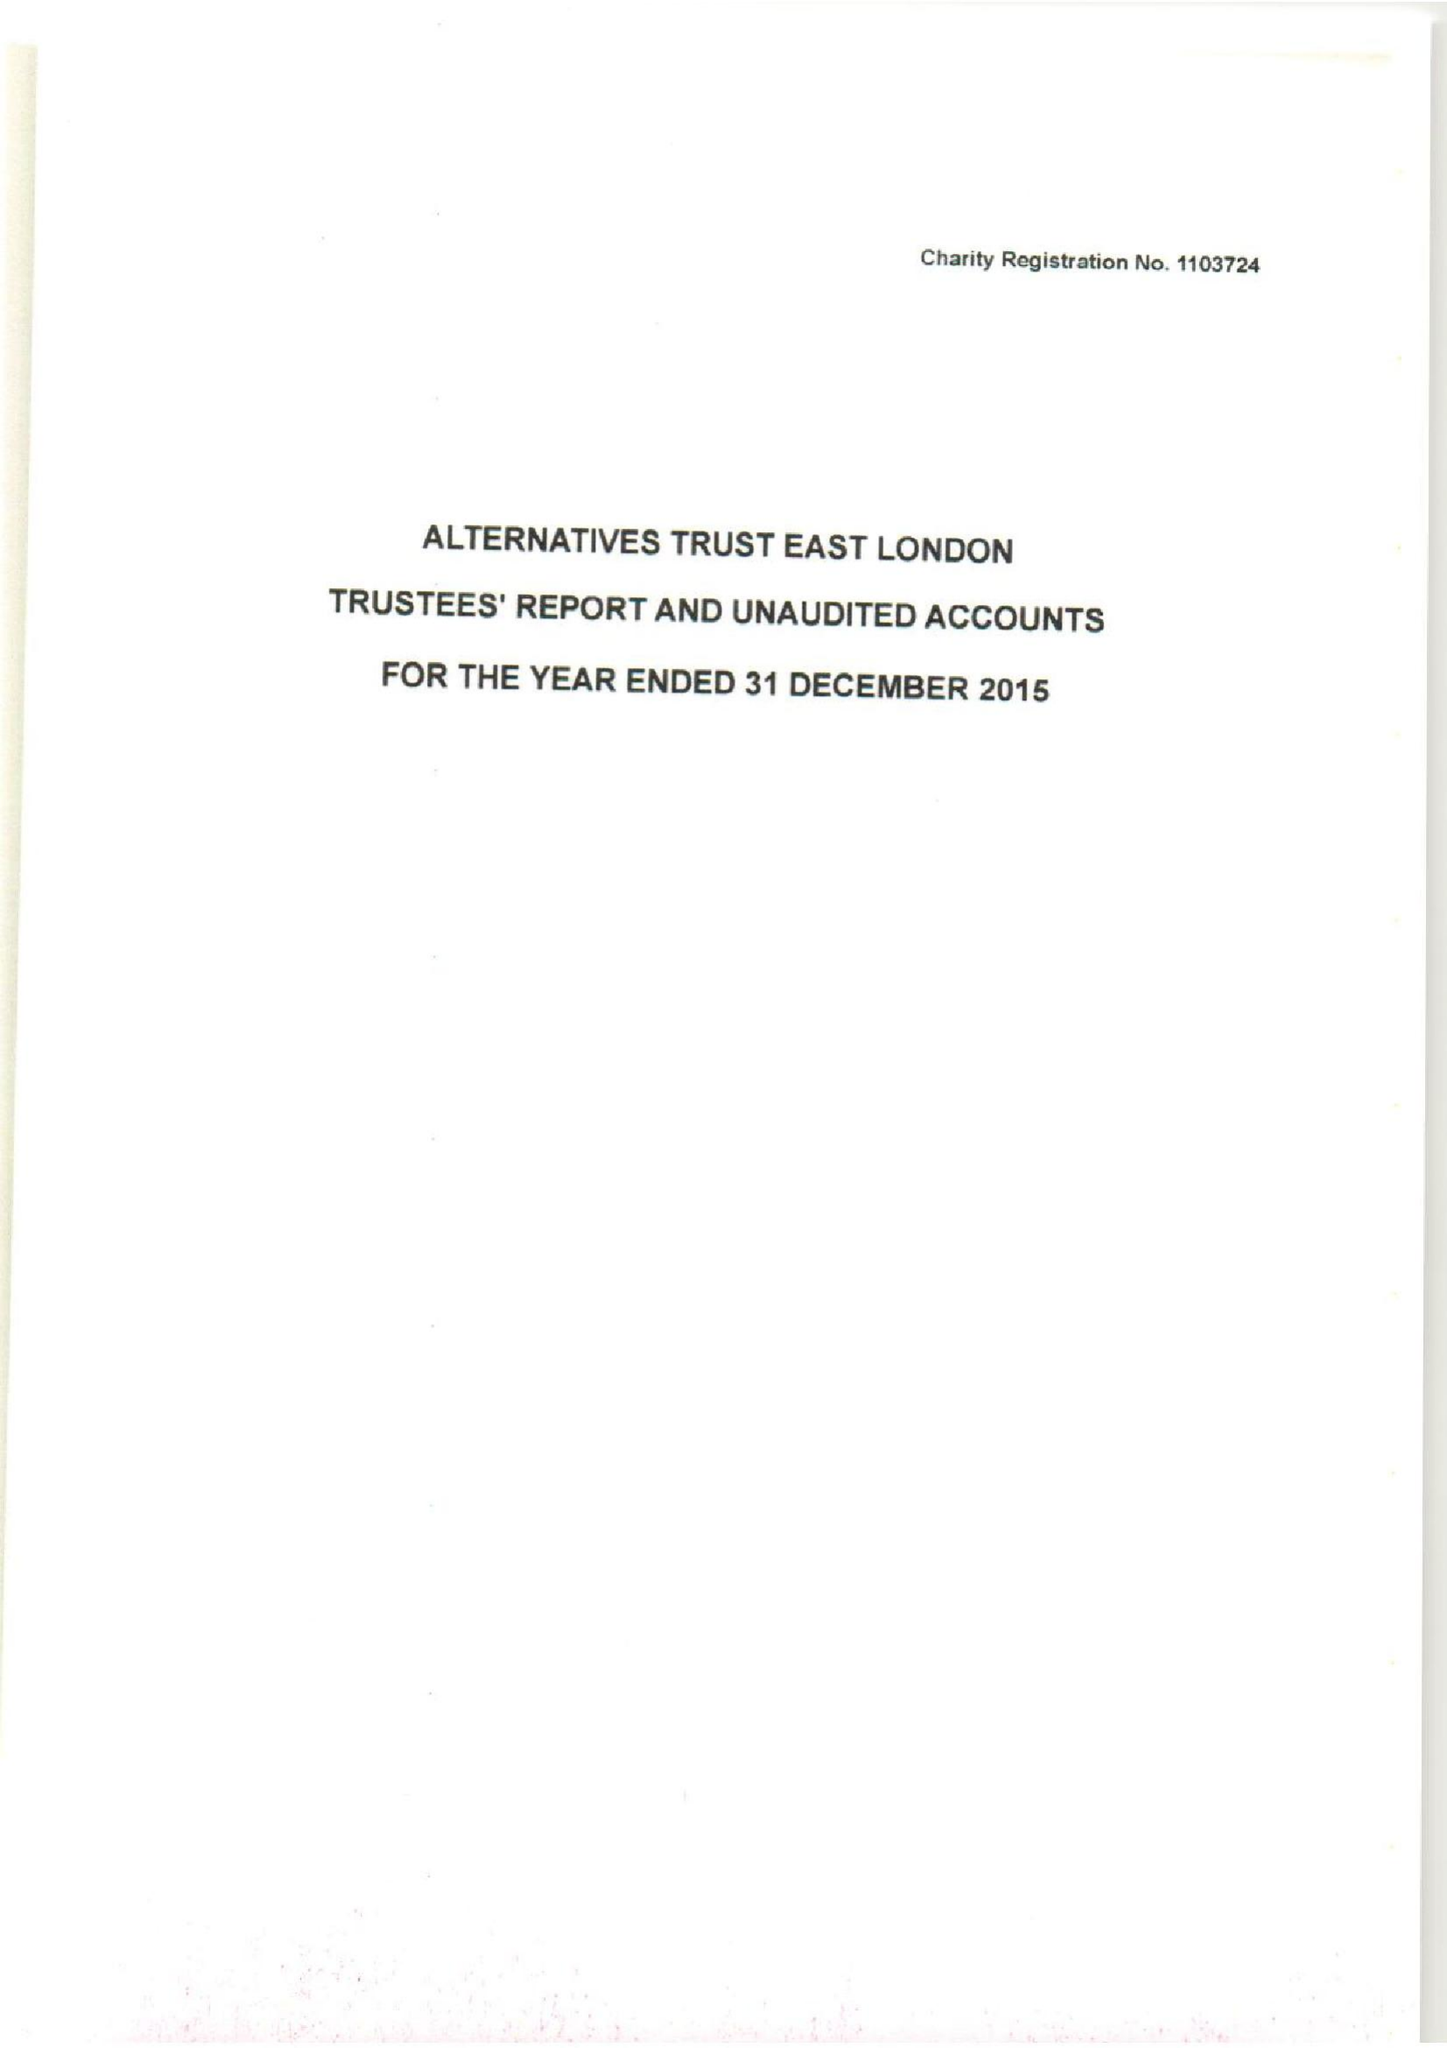What is the value for the report_date?
Answer the question using a single word or phrase. 2015-12-31 